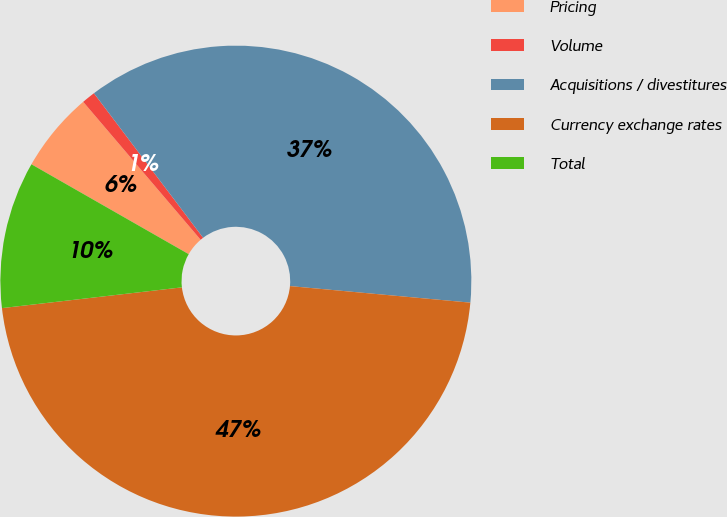Convert chart to OTSL. <chart><loc_0><loc_0><loc_500><loc_500><pie_chart><fcel>Pricing<fcel>Volume<fcel>Acquisitions / divestitures<fcel>Currency exchange rates<fcel>Total<nl><fcel>5.51%<fcel>0.93%<fcel>36.75%<fcel>46.71%<fcel>10.09%<nl></chart> 